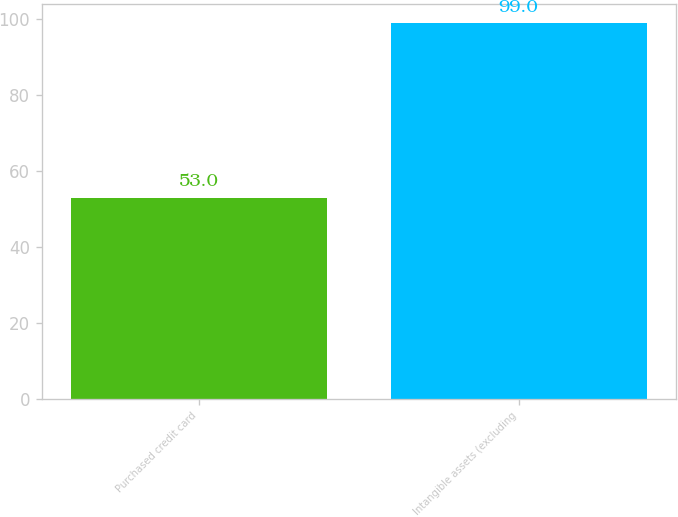Convert chart to OTSL. <chart><loc_0><loc_0><loc_500><loc_500><bar_chart><fcel>Purchased credit card<fcel>Intangible assets (excluding<nl><fcel>53<fcel>99<nl></chart> 